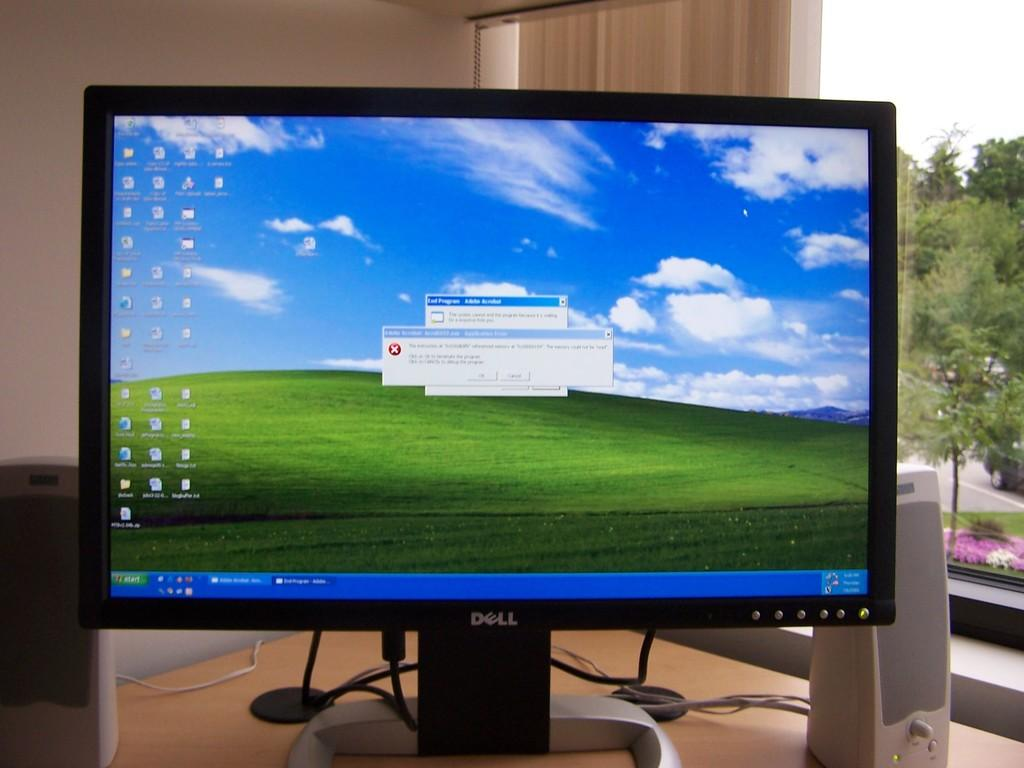Provide a one-sentence caption for the provided image. Dell computer monitor showing a cloudy blue sky. 